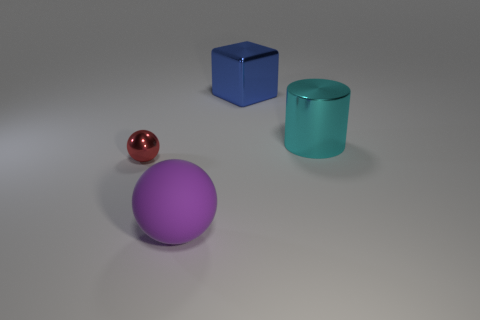Add 3 big metallic cylinders. How many objects exist? 7 Subtract all cylinders. How many objects are left? 3 Add 1 big objects. How many big objects are left? 4 Add 4 small purple shiny objects. How many small purple shiny objects exist? 4 Subtract 0 cyan blocks. How many objects are left? 4 Subtract all large metal cylinders. Subtract all big cyan objects. How many objects are left? 2 